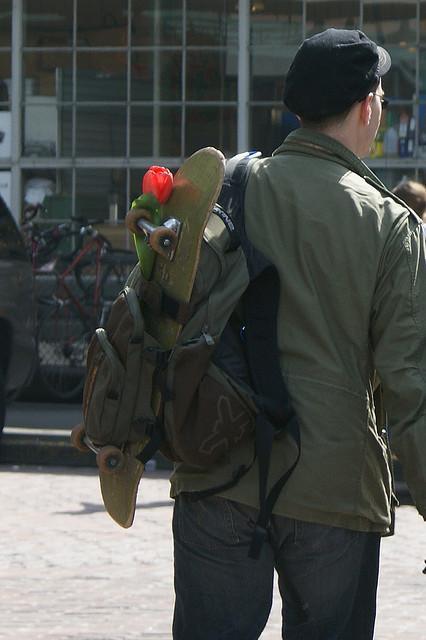How many bicycles are there?
Give a very brief answer. 2. 